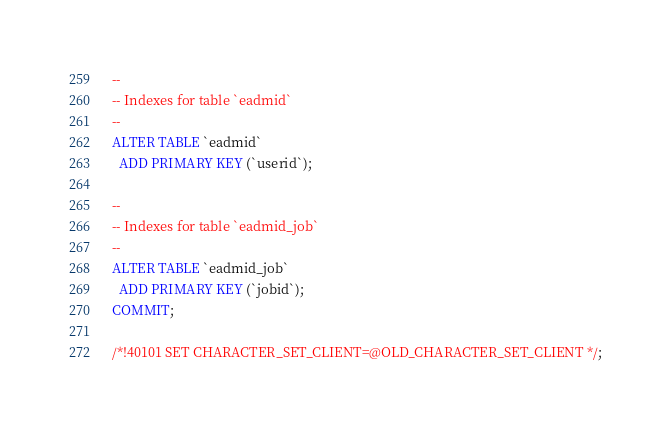Convert code to text. <code><loc_0><loc_0><loc_500><loc_500><_SQL_>--
-- Indexes for table `eadmid`
--
ALTER TABLE `eadmid`
  ADD PRIMARY KEY (`userid`);

--
-- Indexes for table `eadmid_job`
--
ALTER TABLE `eadmid_job`
  ADD PRIMARY KEY (`jobid`);
COMMIT;

/*!40101 SET CHARACTER_SET_CLIENT=@OLD_CHARACTER_SET_CLIENT */;</code> 